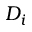<formula> <loc_0><loc_0><loc_500><loc_500>D _ { i }</formula> 